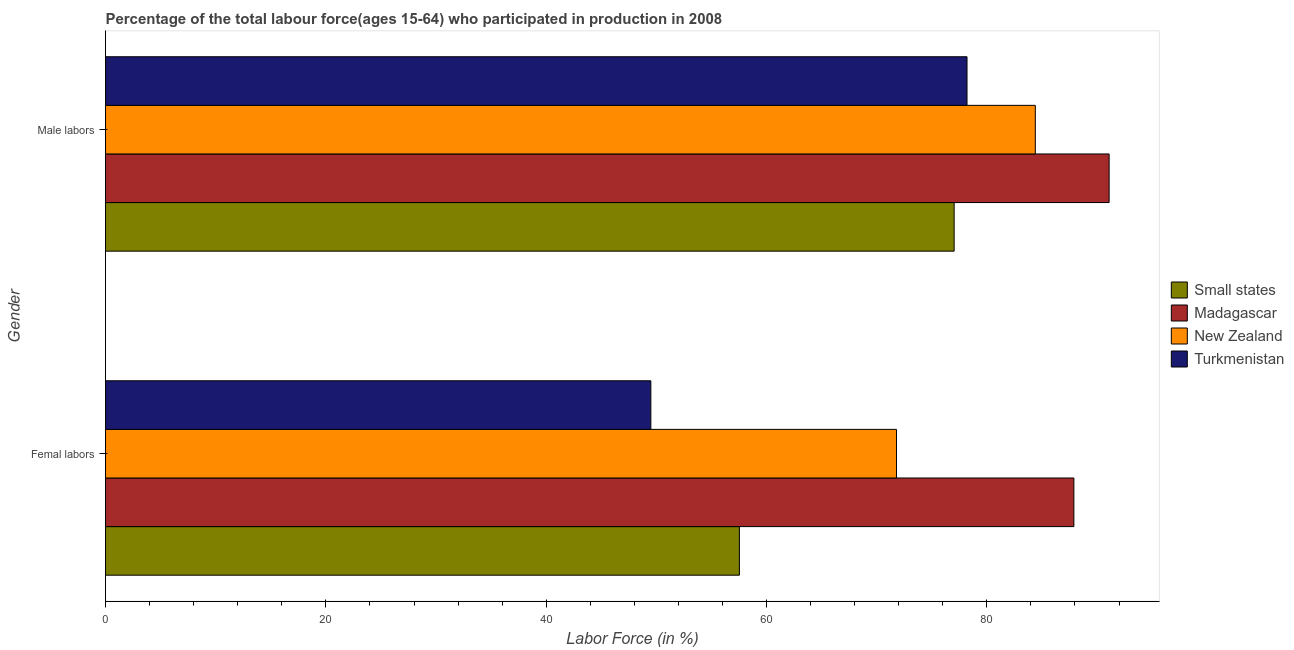How many different coloured bars are there?
Your answer should be very brief. 4. Are the number of bars on each tick of the Y-axis equal?
Give a very brief answer. Yes. How many bars are there on the 2nd tick from the bottom?
Ensure brevity in your answer.  4. What is the label of the 2nd group of bars from the top?
Keep it short and to the point. Femal labors. What is the percentage of male labour force in Small states?
Offer a very short reply. 77.03. Across all countries, what is the maximum percentage of male labour force?
Your response must be concise. 91.1. Across all countries, what is the minimum percentage of male labour force?
Your answer should be compact. 77.03. In which country was the percentage of male labour force maximum?
Your answer should be very brief. Madagascar. In which country was the percentage of female labor force minimum?
Offer a very short reply. Turkmenistan. What is the total percentage of female labor force in the graph?
Keep it short and to the point. 266.74. What is the difference between the percentage of female labor force in Turkmenistan and that in Small states?
Keep it short and to the point. -8.04. What is the average percentage of female labor force per country?
Make the answer very short. 66.68. What is the difference between the percentage of male labour force and percentage of female labor force in Small states?
Your answer should be compact. 19.49. What is the ratio of the percentage of female labor force in New Zealand to that in Madagascar?
Give a very brief answer. 0.82. Is the percentage of male labour force in Small states less than that in Turkmenistan?
Your answer should be very brief. Yes. In how many countries, is the percentage of female labor force greater than the average percentage of female labor force taken over all countries?
Make the answer very short. 2. What does the 4th bar from the top in Male labors represents?
Provide a succinct answer. Small states. What does the 1st bar from the bottom in Male labors represents?
Your answer should be compact. Small states. Are all the bars in the graph horizontal?
Make the answer very short. Yes. What is the difference between two consecutive major ticks on the X-axis?
Give a very brief answer. 20. Are the values on the major ticks of X-axis written in scientific E-notation?
Your response must be concise. No. Does the graph contain grids?
Provide a succinct answer. No. What is the title of the graph?
Give a very brief answer. Percentage of the total labour force(ages 15-64) who participated in production in 2008. Does "Luxembourg" appear as one of the legend labels in the graph?
Make the answer very short. No. What is the label or title of the X-axis?
Make the answer very short. Labor Force (in %). What is the Labor Force (in %) of Small states in Femal labors?
Provide a succinct answer. 57.54. What is the Labor Force (in %) of Madagascar in Femal labors?
Your answer should be very brief. 87.9. What is the Labor Force (in %) of New Zealand in Femal labors?
Provide a succinct answer. 71.8. What is the Labor Force (in %) in Turkmenistan in Femal labors?
Your answer should be very brief. 49.5. What is the Labor Force (in %) of Small states in Male labors?
Make the answer very short. 77.03. What is the Labor Force (in %) in Madagascar in Male labors?
Ensure brevity in your answer.  91.1. What is the Labor Force (in %) in New Zealand in Male labors?
Make the answer very short. 84.4. What is the Labor Force (in %) of Turkmenistan in Male labors?
Offer a terse response. 78.2. Across all Gender, what is the maximum Labor Force (in %) in Small states?
Give a very brief answer. 77.03. Across all Gender, what is the maximum Labor Force (in %) in Madagascar?
Your answer should be compact. 91.1. Across all Gender, what is the maximum Labor Force (in %) of New Zealand?
Your answer should be very brief. 84.4. Across all Gender, what is the maximum Labor Force (in %) in Turkmenistan?
Offer a very short reply. 78.2. Across all Gender, what is the minimum Labor Force (in %) of Small states?
Make the answer very short. 57.54. Across all Gender, what is the minimum Labor Force (in %) of Madagascar?
Make the answer very short. 87.9. Across all Gender, what is the minimum Labor Force (in %) of New Zealand?
Provide a short and direct response. 71.8. Across all Gender, what is the minimum Labor Force (in %) in Turkmenistan?
Make the answer very short. 49.5. What is the total Labor Force (in %) in Small states in the graph?
Offer a terse response. 134.57. What is the total Labor Force (in %) of Madagascar in the graph?
Give a very brief answer. 179. What is the total Labor Force (in %) of New Zealand in the graph?
Provide a succinct answer. 156.2. What is the total Labor Force (in %) of Turkmenistan in the graph?
Provide a succinct answer. 127.7. What is the difference between the Labor Force (in %) in Small states in Femal labors and that in Male labors?
Keep it short and to the point. -19.49. What is the difference between the Labor Force (in %) in Madagascar in Femal labors and that in Male labors?
Give a very brief answer. -3.2. What is the difference between the Labor Force (in %) in Turkmenistan in Femal labors and that in Male labors?
Provide a succinct answer. -28.7. What is the difference between the Labor Force (in %) of Small states in Femal labors and the Labor Force (in %) of Madagascar in Male labors?
Make the answer very short. -33.56. What is the difference between the Labor Force (in %) in Small states in Femal labors and the Labor Force (in %) in New Zealand in Male labors?
Offer a very short reply. -26.86. What is the difference between the Labor Force (in %) of Small states in Femal labors and the Labor Force (in %) of Turkmenistan in Male labors?
Offer a terse response. -20.66. What is the difference between the Labor Force (in %) of Madagascar in Femal labors and the Labor Force (in %) of New Zealand in Male labors?
Give a very brief answer. 3.5. What is the difference between the Labor Force (in %) of Madagascar in Femal labors and the Labor Force (in %) of Turkmenistan in Male labors?
Keep it short and to the point. 9.7. What is the average Labor Force (in %) of Small states per Gender?
Offer a terse response. 67.28. What is the average Labor Force (in %) in Madagascar per Gender?
Ensure brevity in your answer.  89.5. What is the average Labor Force (in %) of New Zealand per Gender?
Give a very brief answer. 78.1. What is the average Labor Force (in %) in Turkmenistan per Gender?
Make the answer very short. 63.85. What is the difference between the Labor Force (in %) of Small states and Labor Force (in %) of Madagascar in Femal labors?
Provide a short and direct response. -30.36. What is the difference between the Labor Force (in %) of Small states and Labor Force (in %) of New Zealand in Femal labors?
Keep it short and to the point. -14.26. What is the difference between the Labor Force (in %) in Small states and Labor Force (in %) in Turkmenistan in Femal labors?
Provide a short and direct response. 8.04. What is the difference between the Labor Force (in %) of Madagascar and Labor Force (in %) of New Zealand in Femal labors?
Offer a very short reply. 16.1. What is the difference between the Labor Force (in %) of Madagascar and Labor Force (in %) of Turkmenistan in Femal labors?
Offer a terse response. 38.4. What is the difference between the Labor Force (in %) in New Zealand and Labor Force (in %) in Turkmenistan in Femal labors?
Your answer should be compact. 22.3. What is the difference between the Labor Force (in %) in Small states and Labor Force (in %) in Madagascar in Male labors?
Offer a terse response. -14.07. What is the difference between the Labor Force (in %) in Small states and Labor Force (in %) in New Zealand in Male labors?
Offer a very short reply. -7.37. What is the difference between the Labor Force (in %) in Small states and Labor Force (in %) in Turkmenistan in Male labors?
Your response must be concise. -1.17. What is the difference between the Labor Force (in %) of Madagascar and Labor Force (in %) of Turkmenistan in Male labors?
Give a very brief answer. 12.9. What is the ratio of the Labor Force (in %) in Small states in Femal labors to that in Male labors?
Provide a succinct answer. 0.75. What is the ratio of the Labor Force (in %) of Madagascar in Femal labors to that in Male labors?
Your response must be concise. 0.96. What is the ratio of the Labor Force (in %) of New Zealand in Femal labors to that in Male labors?
Offer a terse response. 0.85. What is the ratio of the Labor Force (in %) of Turkmenistan in Femal labors to that in Male labors?
Make the answer very short. 0.63. What is the difference between the highest and the second highest Labor Force (in %) of Small states?
Your answer should be compact. 19.49. What is the difference between the highest and the second highest Labor Force (in %) in New Zealand?
Offer a very short reply. 12.6. What is the difference between the highest and the second highest Labor Force (in %) in Turkmenistan?
Keep it short and to the point. 28.7. What is the difference between the highest and the lowest Labor Force (in %) of Small states?
Give a very brief answer. 19.49. What is the difference between the highest and the lowest Labor Force (in %) in New Zealand?
Make the answer very short. 12.6. What is the difference between the highest and the lowest Labor Force (in %) in Turkmenistan?
Your answer should be very brief. 28.7. 